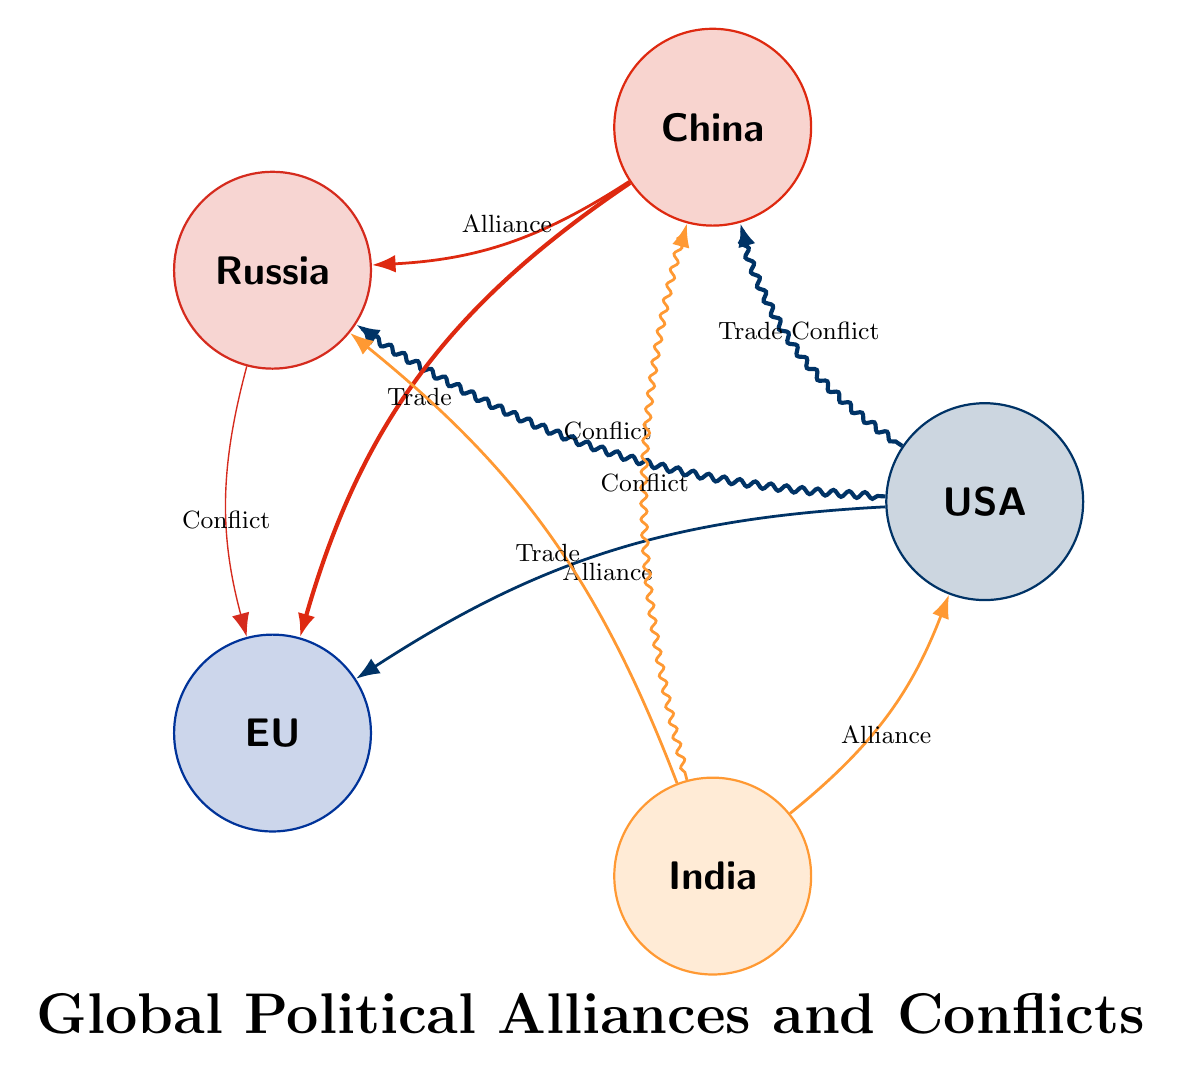What countries are represented in the diagram? The diagram shows five nodes which are the countries: USA, China, Russia, European Union, and India.
Answer: USA, China, Russia, European Union, India How many alliances are depicted in the diagram? There are alliances represented by chords between USA and EU, China and Russia, and India and USA, totaling three alliances.
Answer: 3 What type of relationship exists between China and the European Union? The relationship between China and the European Union is denoted as a trade relationship.
Answer: Trade Which country has a high conflict with the USA? The diagram indicates a high conflict type relationship between the USA and Russia, evidenced by the significant chord.
Answer: Russia Which two countries are involved in a medium intensity conflict? The diagram shows a medium intensity conflict between India and China, indicated by the chord with this particular intensity label.
Answer: India and China How many countries have conflict relationships in total? The countries involved in conflicts based on the diagram are USA, China, and Russia, making a total of four conflict relationships with the mentioned countries.
Answer: 4 Which country has a low conflict relationship with Russia? The relationship between Russia and the European Union is classified as a low conflict, as indicated by the corresponding chord.
Answer: European Union Is there a high intensity trade relationship in the diagram? Yes, there is a high intensity trade relationship depicted between China and the European Union.
Answer: Yes Which country has an alliance with both USA and Russia? The diagram indicates that India has an alliance with the USA, but does not have an alliance with Russia; India only has a trade relationship with Russia.
Answer: USA 